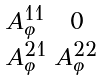<formula> <loc_0><loc_0><loc_500><loc_500>\begin{smallmatrix} A ^ { 1 1 } _ { \varphi } & 0 \\ A ^ { 2 1 } _ { \varphi } & A ^ { 2 2 } _ { \varphi } \end{smallmatrix}</formula> 